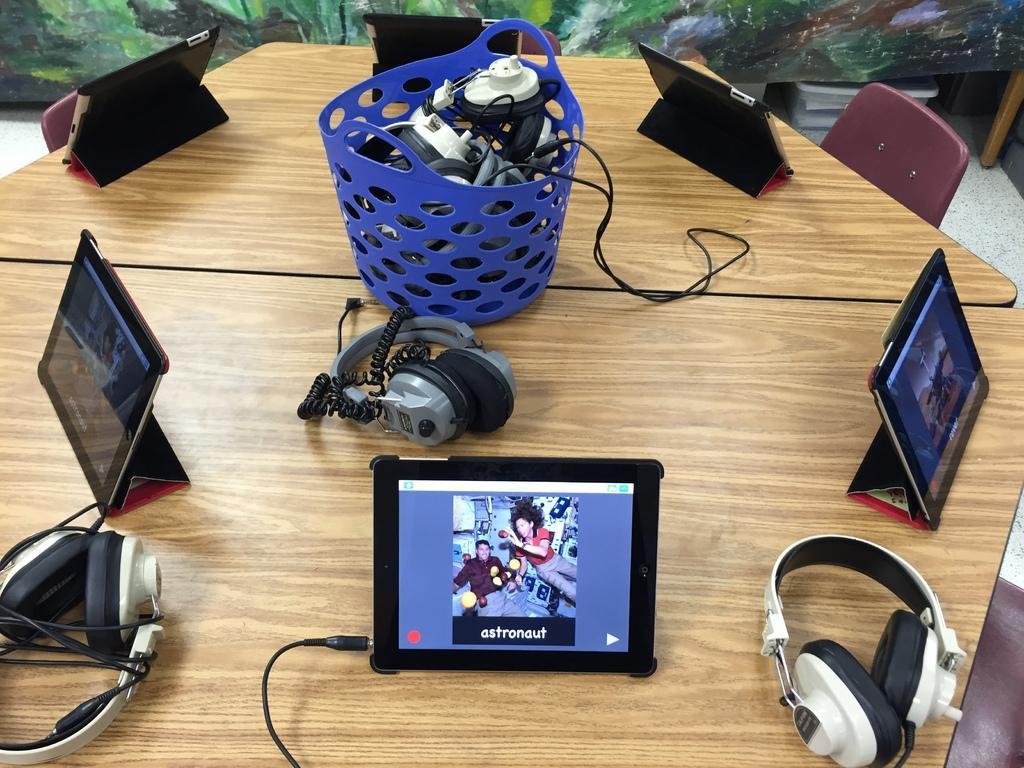Can you describe this image briefly? In this image we can see a table and on the table there are basket which consists of cables and headphones, tables and chairs. 